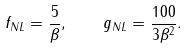Convert formula to latex. <formula><loc_0><loc_0><loc_500><loc_500>f _ { N L } = \frac { 5 } { \beta } , \quad g _ { N L } = \frac { 1 0 0 } { 3 \beta ^ { 2 } } .</formula> 